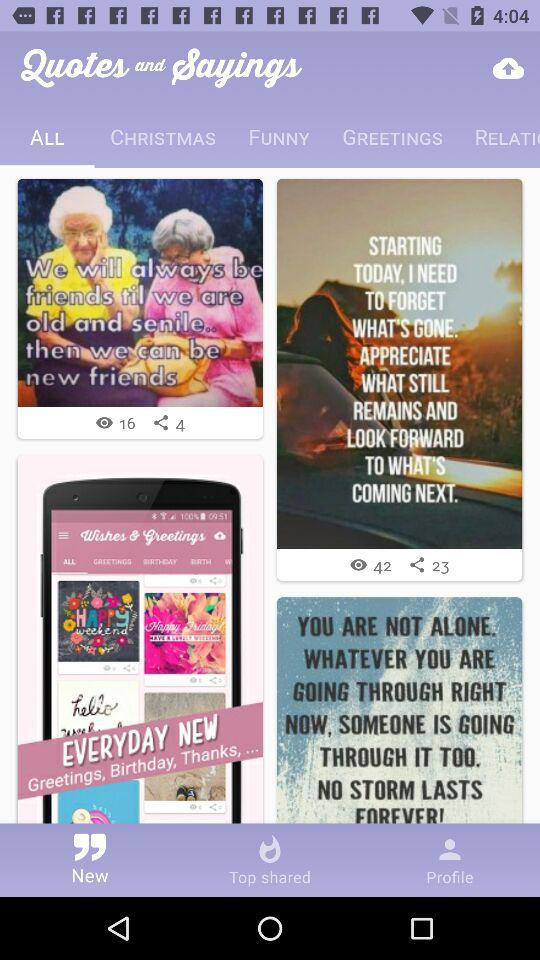Which tab has been selected? The selected tabs are "New" and "ALL". 